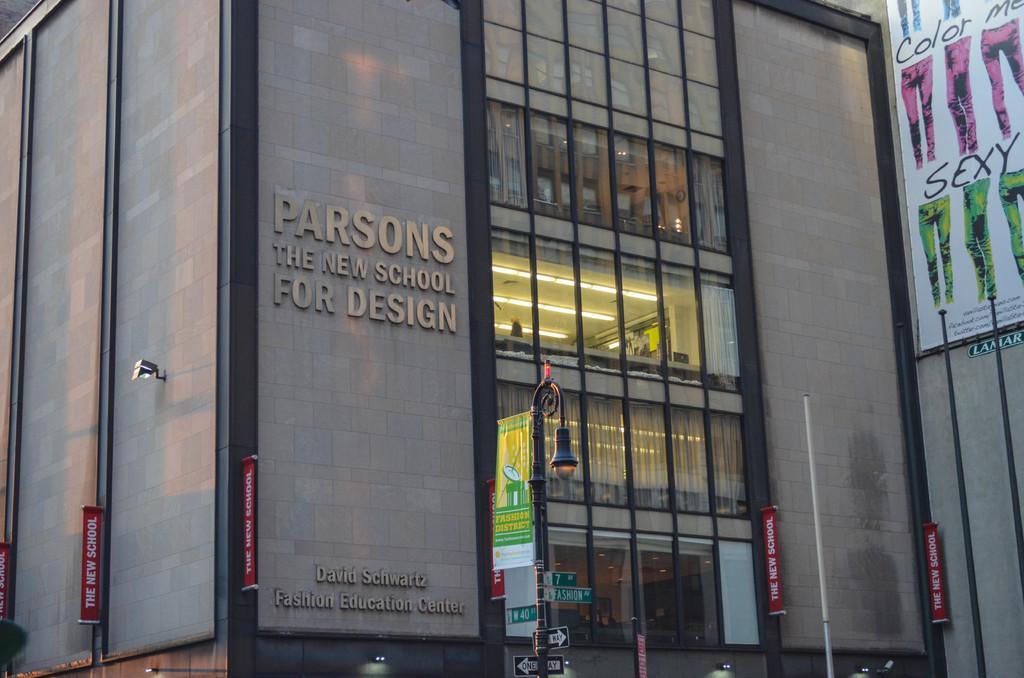How would you summarize this image in a sentence or two? In this image there is a street light having few boards attached to the pole. Right side there are poles. Right top there is a banner attached to the wall of a building. 